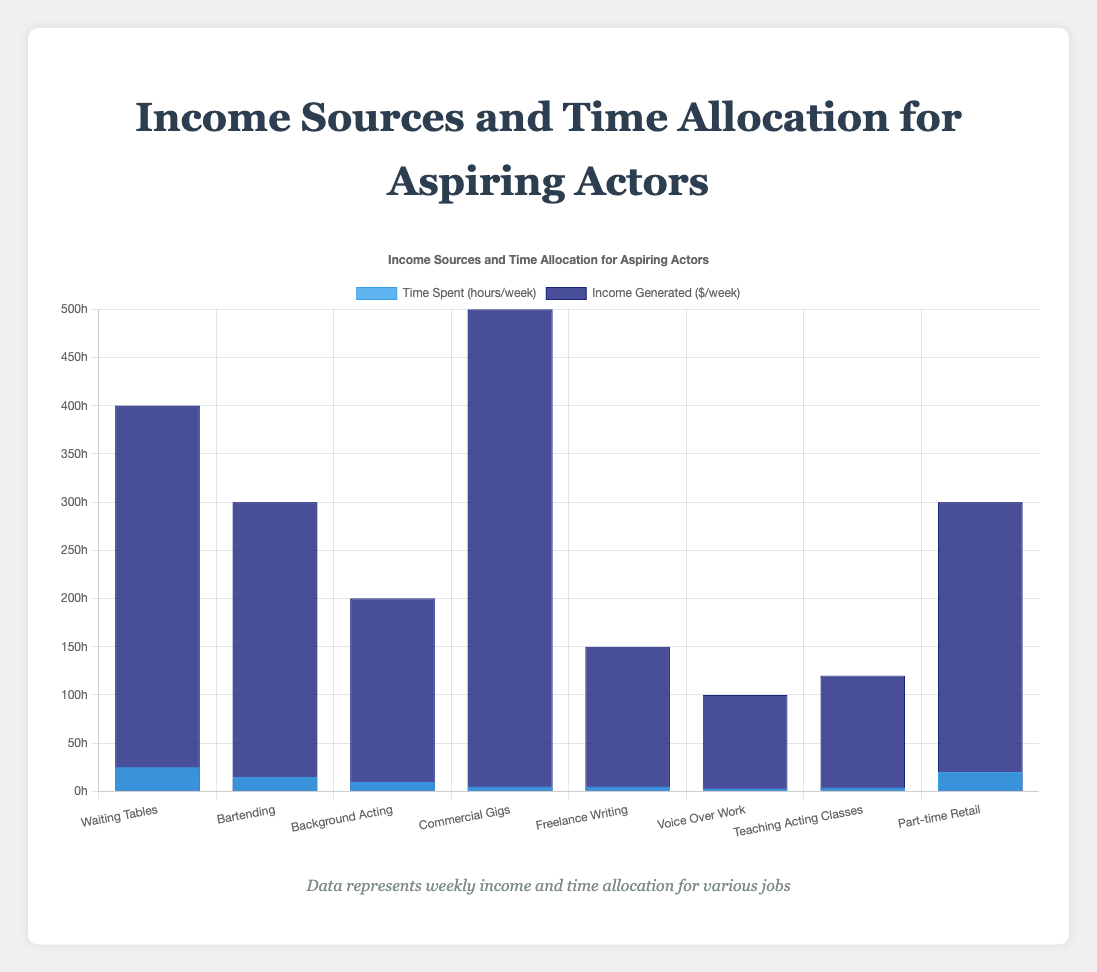What's the total time spent per week by the aspiring actor on all income sources combined? Sum the time spent on each income source: 25 (Waiting Tables) + 15 (Bartending) + 10 (Background Acting) + 5 (Commercial Gigs) + 5 (Freelance Writing) + 3 (Voice Over Work) + 4 (Teaching Acting Classes) + 20 (Part-time Retail) = 87 hours
Answer: 87 hours Which job generates the highest income per week? Compare the income figures: 400 (Waiting Tables), 300 (Bartending), 200 (Background Acting), 500 (Commercial Gigs), 150 (Freelance Writing), 100 (Voice Over Work), 120 (Teaching Acting Classes), 300 (Part-time Retail). The highest income is from Commercial Gigs at $500 per week
Answer: Commercial Gigs How much more time does the actor spend on Waiting Tables compared to Bartending? Subtract time spent on Bartending from Waiting Tables: 25 (Waiting Tables) - 15 (Bartending) = 10 hours more
Answer: 10 hours What is the difference in income generated per week between Waiting Tables and Part-time Retail? Subtract income from Part-time Retail from Waiting Tables: $400 (Waiting Tables) - $300 (Part-time Retail) = $100
Answer: $100 Which job requires the least amount of time per week? Compare time spent on each job: 25, 15, 10, 5, 5, 3, 4, 20. Voice Over Work requires the least time at 3 hours per week
Answer: Voice Over Work What is the average income generated per week from all income sources? Sum the weekly income and divide by the number of income sources: (400 + 300 + 200 + 500 + 150 + 100 + 120 + 300) / 8 = 2070 / 8 = $258.75
Answer: $258.75 Which income source generates more income per hour worked, Waiting Tables or Background Acting? Calculate income per hour for both: Waiting Tables: $400 / 25 = $16/hour; Background Acting: $200 / 10 = $20/hour. Background Acting generates more per hour
Answer: Background Acting How much more weekly income does Commercial Gigs generate compared to Freelance Writing? Subtract income from Freelance Writing from Commercial Gigs: $500 (Commercial Gigs) - $150 (Freelance Writing) = $350
Answer: $350 Which job has the widest bar in the chart when considering time spent and income generated? Compare the visual appearance of bars for both metrics for each job. Waiting Tables has the widest bar for time spent, and Commercial Gigs has the widest bar for income generated. Considering both metrics, Commercial Gigs would be more visually distinct due to high income albeit lower time spent
Answer: Commercial Gigs 